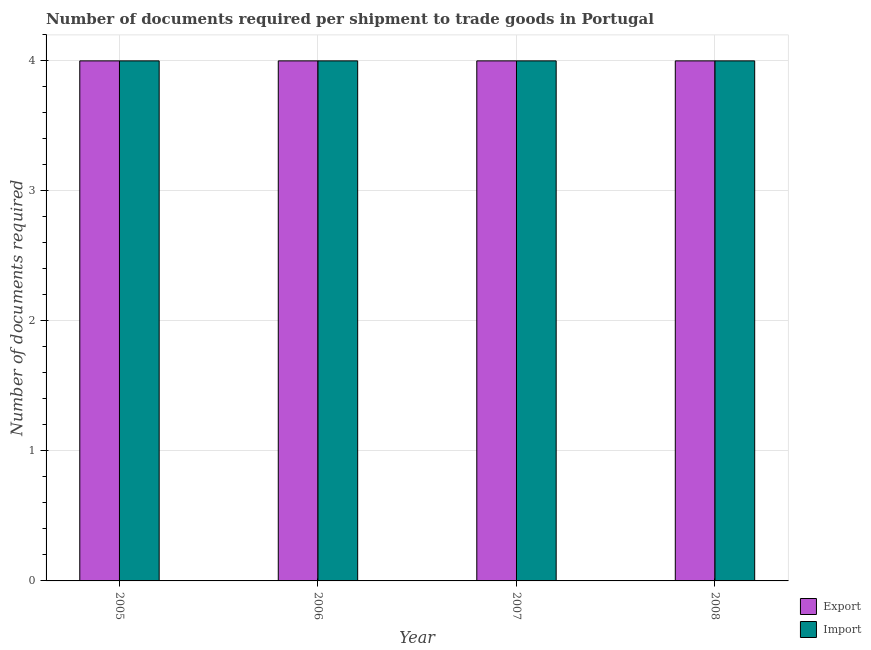Are the number of bars per tick equal to the number of legend labels?
Ensure brevity in your answer.  Yes. What is the number of documents required to export goods in 2007?
Keep it short and to the point. 4. Across all years, what is the maximum number of documents required to import goods?
Make the answer very short. 4. Across all years, what is the minimum number of documents required to import goods?
Provide a succinct answer. 4. What is the total number of documents required to import goods in the graph?
Make the answer very short. 16. In how many years, is the number of documents required to export goods greater than 3.2?
Make the answer very short. 4. Is the number of documents required to import goods in 2005 less than that in 2008?
Keep it short and to the point. No. Is the difference between the number of documents required to import goods in 2005 and 2007 greater than the difference between the number of documents required to export goods in 2005 and 2007?
Offer a very short reply. No. What is the difference between the highest and the second highest number of documents required to import goods?
Keep it short and to the point. 0. What is the difference between the highest and the lowest number of documents required to export goods?
Provide a succinct answer. 0. What does the 2nd bar from the left in 2007 represents?
Offer a very short reply. Import. What does the 2nd bar from the right in 2006 represents?
Your answer should be compact. Export. How many bars are there?
Your answer should be very brief. 8. How many years are there in the graph?
Provide a succinct answer. 4. Are the values on the major ticks of Y-axis written in scientific E-notation?
Your response must be concise. No. Does the graph contain any zero values?
Give a very brief answer. No. Where does the legend appear in the graph?
Your answer should be very brief. Bottom right. How many legend labels are there?
Give a very brief answer. 2. How are the legend labels stacked?
Your answer should be compact. Vertical. What is the title of the graph?
Make the answer very short. Number of documents required per shipment to trade goods in Portugal. What is the label or title of the Y-axis?
Your answer should be compact. Number of documents required. What is the Number of documents required of Export in 2005?
Ensure brevity in your answer.  4. What is the Number of documents required in Import in 2006?
Your answer should be compact. 4. What is the Number of documents required in Export in 2007?
Your answer should be very brief. 4. Across all years, what is the maximum Number of documents required in Export?
Provide a succinct answer. 4. Across all years, what is the maximum Number of documents required of Import?
Your response must be concise. 4. Across all years, what is the minimum Number of documents required in Import?
Offer a terse response. 4. What is the total Number of documents required in Export in the graph?
Your response must be concise. 16. What is the total Number of documents required in Import in the graph?
Make the answer very short. 16. What is the difference between the Number of documents required in Import in 2005 and that in 2008?
Your answer should be compact. 0. What is the difference between the Number of documents required in Export in 2006 and that in 2007?
Offer a terse response. 0. What is the difference between the Number of documents required of Import in 2006 and that in 2007?
Provide a succinct answer. 0. What is the difference between the Number of documents required in Import in 2006 and that in 2008?
Your response must be concise. 0. What is the difference between the Number of documents required in Export in 2007 and that in 2008?
Give a very brief answer. 0. What is the difference between the Number of documents required in Import in 2007 and that in 2008?
Ensure brevity in your answer.  0. What is the difference between the Number of documents required of Export in 2005 and the Number of documents required of Import in 2006?
Provide a succinct answer. 0. What is the difference between the Number of documents required in Export in 2005 and the Number of documents required in Import in 2008?
Make the answer very short. 0. What is the difference between the Number of documents required in Export in 2006 and the Number of documents required in Import in 2007?
Your answer should be compact. 0. What is the average Number of documents required of Import per year?
Give a very brief answer. 4. In the year 2005, what is the difference between the Number of documents required in Export and Number of documents required in Import?
Give a very brief answer. 0. In the year 2007, what is the difference between the Number of documents required in Export and Number of documents required in Import?
Your response must be concise. 0. What is the ratio of the Number of documents required in Export in 2005 to that in 2006?
Provide a succinct answer. 1. What is the ratio of the Number of documents required of Import in 2006 to that in 2007?
Your response must be concise. 1. What is the ratio of the Number of documents required in Import in 2006 to that in 2008?
Give a very brief answer. 1. What is the difference between the highest and the lowest Number of documents required of Import?
Give a very brief answer. 0. 